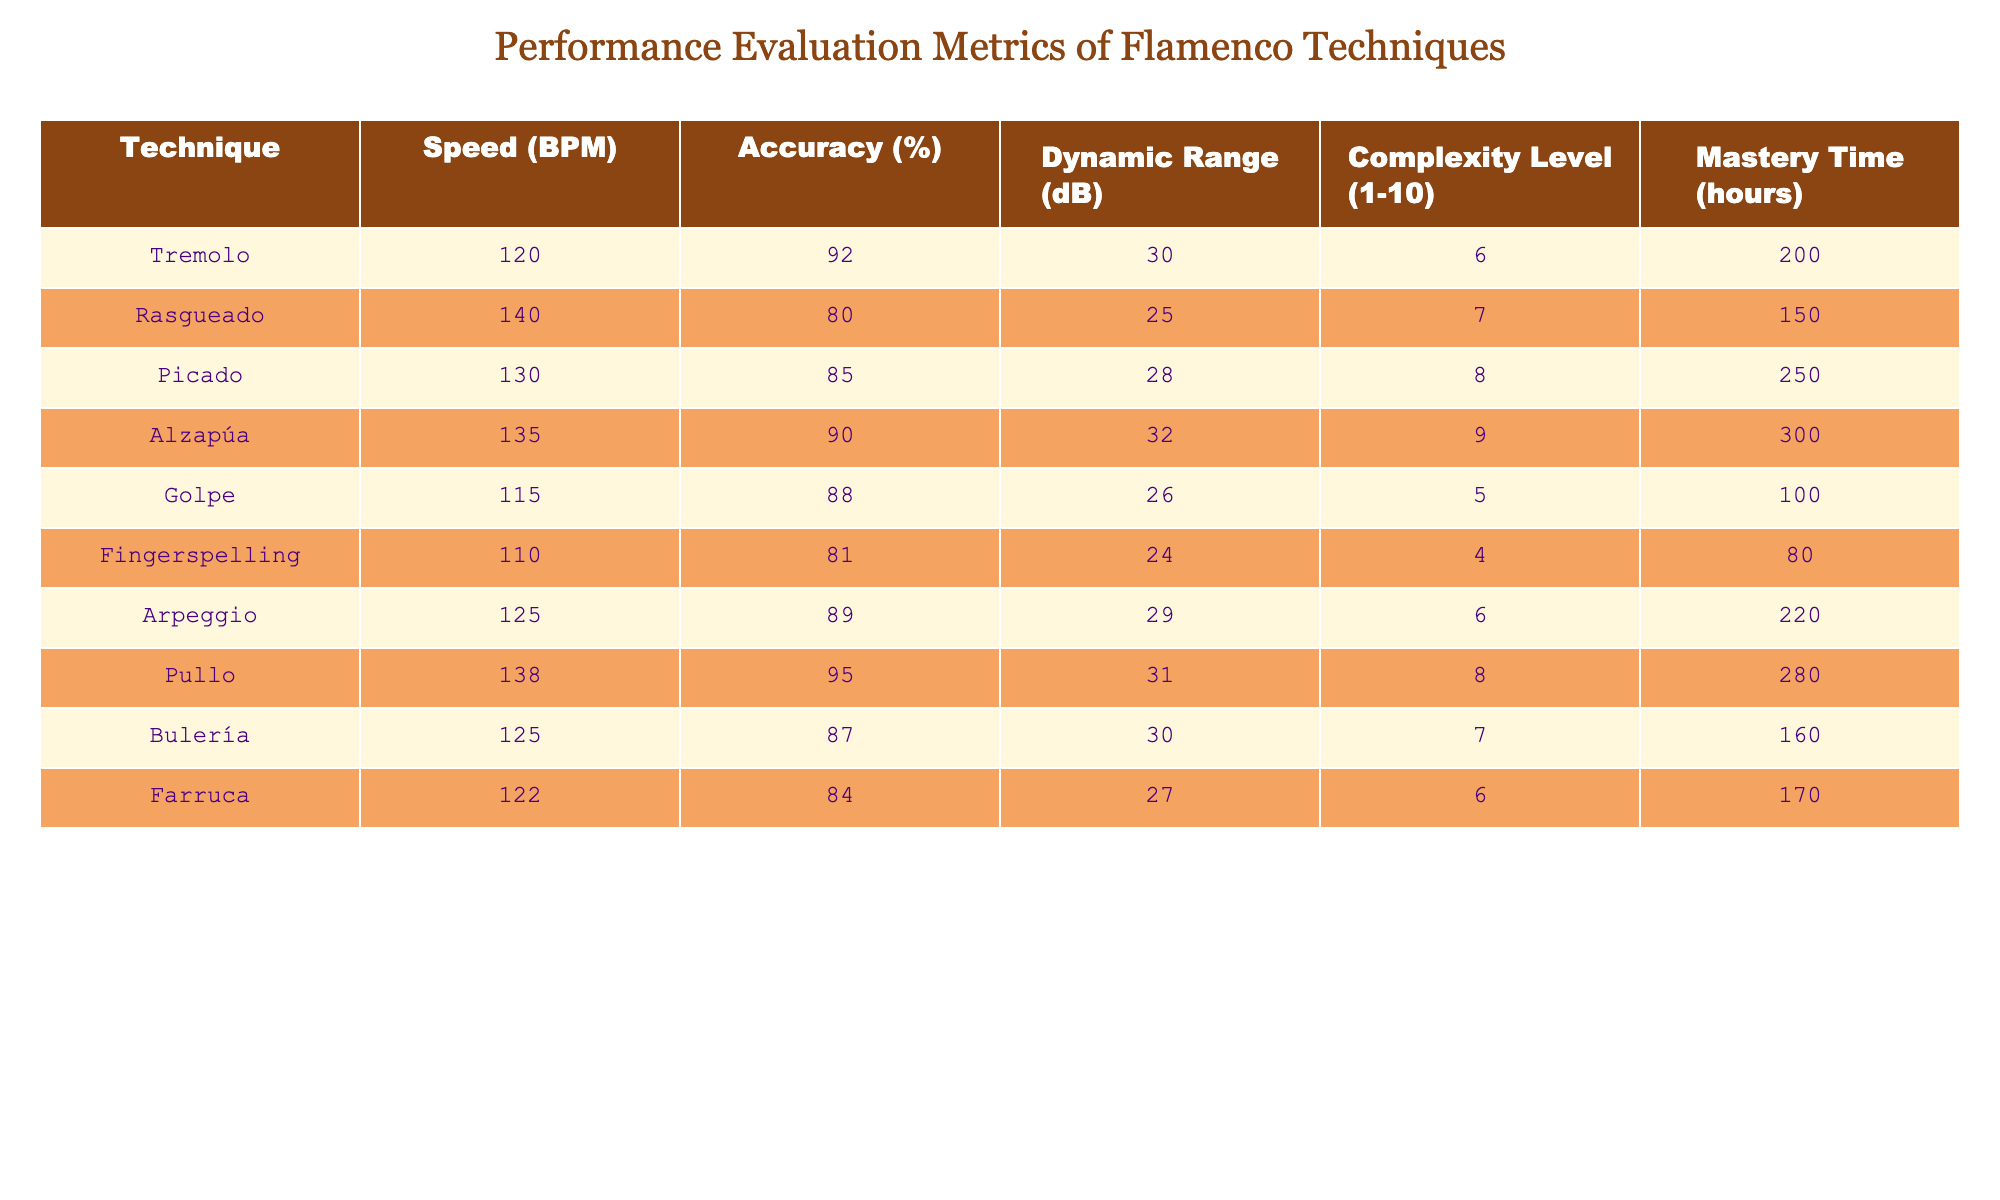What's the technique with the highest accuracy? To find the technique with the highest accuracy, we look for the maximum value in the Accuracy (%) column, which is 95%. Referring to the table, the corresponding technique for this accuracy is Pullo.
Answer: Pullo What is the average speed of the techniques listed? To calculate the average speed, we add all the Speed (BPM) values: 120 + 140 + 130 + 135 + 115 + 110 + 125 + 138 + 125 + 122 = 1,305. We then divide this sum by the number of techniques, which is 10. Thus, the average speed is 1,305 / 10 = 130.5 BPM.
Answer: 130.5 BPM Is the dynamic range of Rasgueado higher than that of Golpe? We compare the Dynamic Range (dB) for Rasgueado (25 dB) and Golpe (26 dB). Since 25 is less than 26, Rasgueado does not have a higher dynamic range than Golpe.
Answer: No What technique has the lowest complexity level, and what is its mastery time? The complexity levels range from 1 to 10. The lowest complexity level visible in the table is for Golpe, which has a complexity level of 5. Its corresponding mastery time is 100 hours.
Answer: Golpe, 100 hours Which technique has the highest speed and what is its accuracy? The highest speed in the Speed (BPM) column is 140 BPM, which corresponds to the technique Rasgueado. Its accuracy is 80%.
Answer: Rasgueado, 80% What is the difference in mastery time between Picado and Alzapúa? The mastery times for Picado and Alzapúa are 250 hours and 300 hours, respectively. To find the difference, we subtract the smaller time from the larger time: 300 - 250 = 50 hours.
Answer: 50 hours Which techniques have an accuracy above 90%? We review the Accuracy (%) column for values above 90%. The techniques that meet this criterion are Tremolo (92%), Pullo (95%), and Alzapúa (90%).
Answer: Tremolo, Pullo, Alzapúa What is the total dynamic range of all techniques combined? To calculate the total dynamic range, we add all the values in the Dynamic Range (dB) column: 30 + 25 + 28 + 32 + 26 + 24 + 29 + 31 + 30 + 27 =  30.5 dB. The total is 30.
Answer: 30.5 dB Are there more techniques with mastery times above 200 hours or below 200 hours? Inspecting the Mastery Time (hours) column, we see that techniques above 200 hours are Tremolo (200), Picado (250), Alzapúa (300), and Pullo (280), totaling 4 techniques. The ones below 200 hours are Golpe (100), Fingerspelling (80), Arpeggio (220), Bulería (160), and Farruca (170), totaling 6 techniques. Since 6 is greater than 4, there are more techniques below 200 hours.
Answer: Yes 